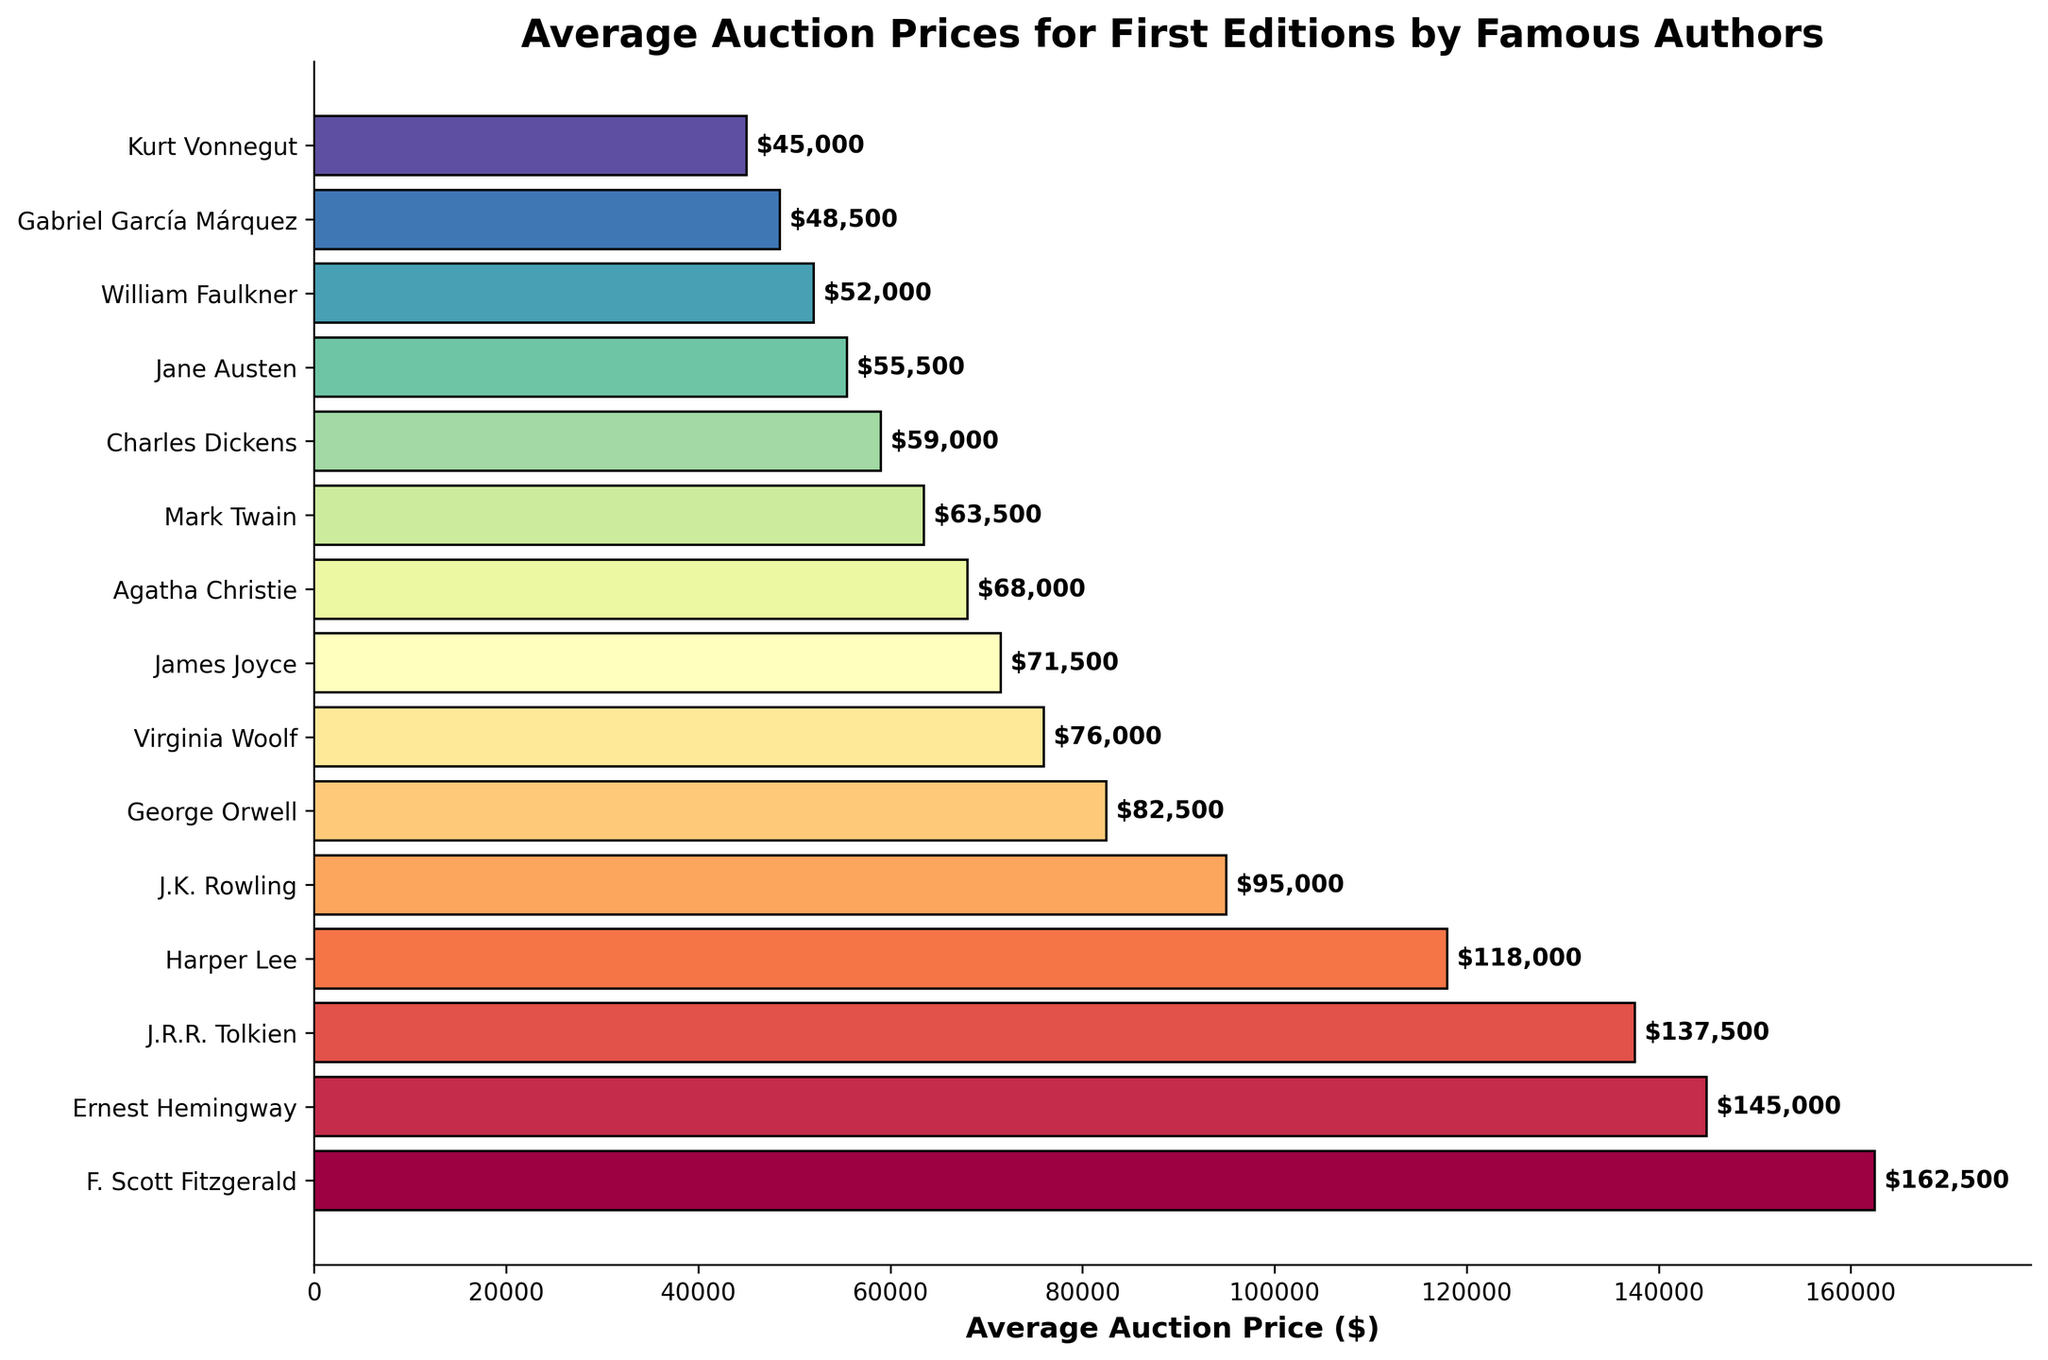How much higher is F. Scott Fitzgerald's average auction price compared to Jane Austen's? F. Scott Fitzgerald's price is $162,500 and Jane Austen's price is $55,500. Subtraction: $162,500 - $55,500 = $107,000
Answer: $107,000 Which author has the third highest average auction price? By visually inspecting the bar lengths and labels, the third highest value corresponds to J.R.R. Tolkien with a price of $137,500
Answer: J.R.R. Tolkien How much is the combined average auction price of Ernest Hemingway and Harper Lee? Identifying the prices as $145,000 (Hemingway) and $118,000 (Lee), we add them: $145,000 + $118,000 = $263,000
Answer: $263,000 Which author has a lower average auction price: Virginia Woolf or Mark Twain? By comparing the prices, Virginia Woolf has $76,000 and Mark Twain has $63,500. Since $63,500 is less than $76,000, Mark Twain has the lower price
Answer: Mark Twain What is the range of the average auction prices? First, identify the highest price ($162,500 for Fitzgerald) and the lowest price ($45,000 for Vonnegut). The range is $162,500 - $45,000 = $117,500
Answer: $117,500 Which author is represented by the color at the bottom of the blended bars? The bar at the bottom corresponds to the lowest average auction price, which is Kurt Vonnegut at $45,000
Answer: Kurt Vonnegut What's the difference between the average auction price of J.K. Rowling and George Orwell? J.K. Rowling has $95,000 and George Orwell has $82,500. The difference is $95,000 - $82,500 = $12,500
Answer: $12,500 Are there more authors with average auction prices above or below $100,000? Counting from the bars, there are 4 above $100,000 and 11 below $100,000. Thus, there are more authors below $100,000
Answer: Below $100,000 Which author's average auction price is closest to $100,000? Comparing the prices, J.K. Rowling at $95,000 is the closest to $100,000
Answer: J.K. Rowling 